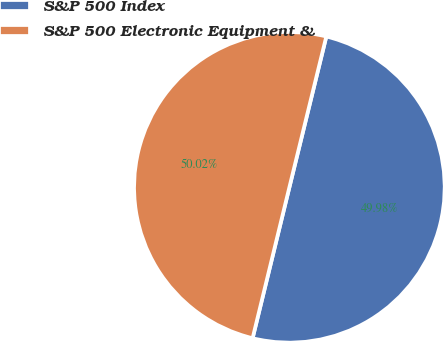<chart> <loc_0><loc_0><loc_500><loc_500><pie_chart><fcel>S&P 500 Index<fcel>S&P 500 Electronic Equipment &<nl><fcel>49.98%<fcel>50.02%<nl></chart> 